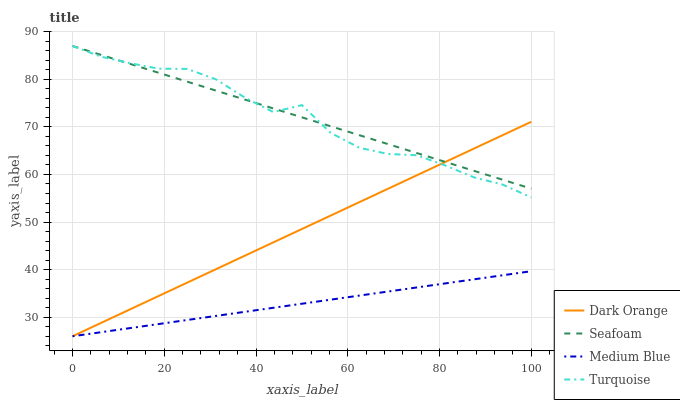Does Medium Blue have the minimum area under the curve?
Answer yes or no. Yes. Does Seafoam have the maximum area under the curve?
Answer yes or no. Yes. Does Turquoise have the minimum area under the curve?
Answer yes or no. No. Does Turquoise have the maximum area under the curve?
Answer yes or no. No. Is Medium Blue the smoothest?
Answer yes or no. Yes. Is Turquoise the roughest?
Answer yes or no. Yes. Is Turquoise the smoothest?
Answer yes or no. No. Is Medium Blue the roughest?
Answer yes or no. No. Does Dark Orange have the lowest value?
Answer yes or no. Yes. Does Turquoise have the lowest value?
Answer yes or no. No. Does Seafoam have the highest value?
Answer yes or no. Yes. Does Medium Blue have the highest value?
Answer yes or no. No. Is Medium Blue less than Turquoise?
Answer yes or no. Yes. Is Turquoise greater than Medium Blue?
Answer yes or no. Yes. Does Dark Orange intersect Medium Blue?
Answer yes or no. Yes. Is Dark Orange less than Medium Blue?
Answer yes or no. No. Is Dark Orange greater than Medium Blue?
Answer yes or no. No. Does Medium Blue intersect Turquoise?
Answer yes or no. No. 